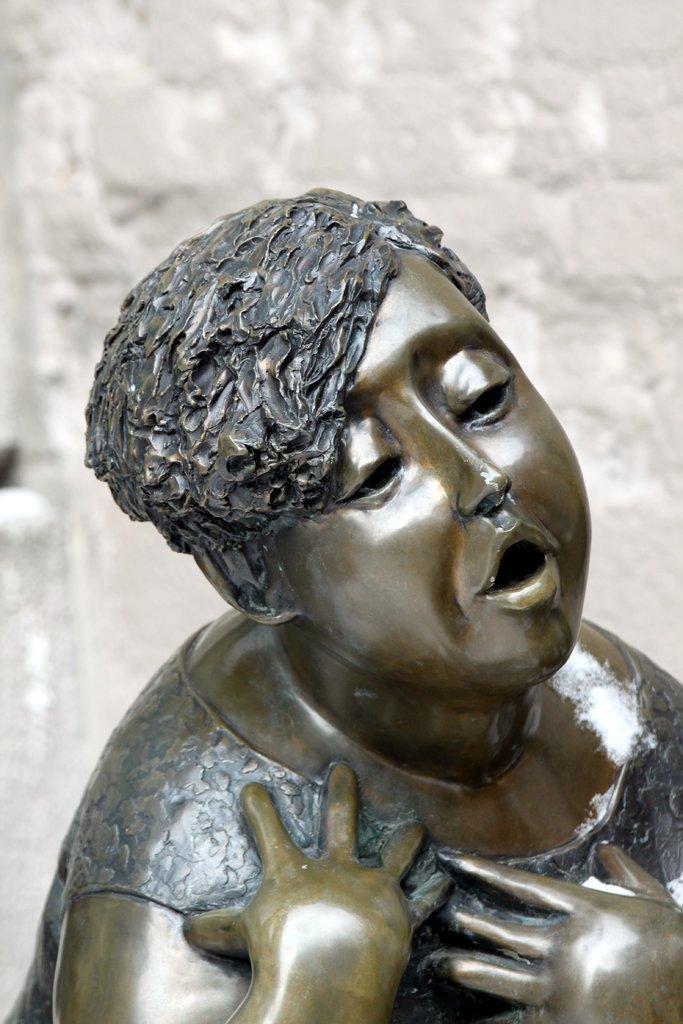Can you describe this image briefly? In front of the picture, we see the statue of the boy. In the background, we see a wall which is white in color. 